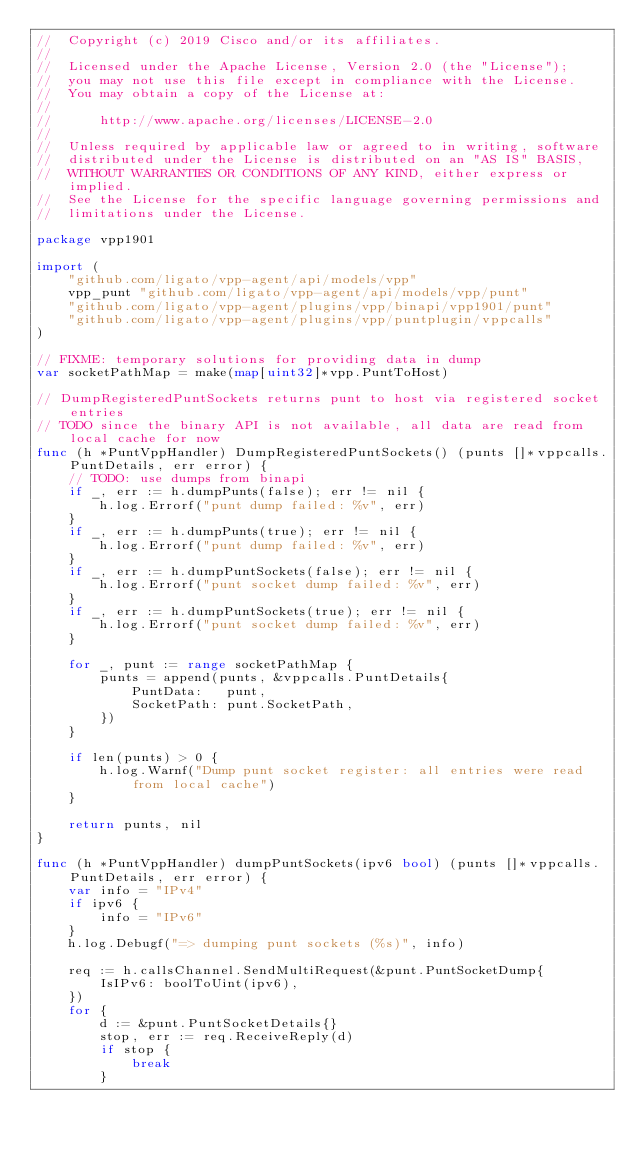Convert code to text. <code><loc_0><loc_0><loc_500><loc_500><_Go_>//  Copyright (c) 2019 Cisco and/or its affiliates.
//
//  Licensed under the Apache License, Version 2.0 (the "License");
//  you may not use this file except in compliance with the License.
//  You may obtain a copy of the License at:
//
//      http://www.apache.org/licenses/LICENSE-2.0
//
//  Unless required by applicable law or agreed to in writing, software
//  distributed under the License is distributed on an "AS IS" BASIS,
//  WITHOUT WARRANTIES OR CONDITIONS OF ANY KIND, either express or implied.
//  See the License for the specific language governing permissions and
//  limitations under the License.

package vpp1901

import (
	"github.com/ligato/vpp-agent/api/models/vpp"
	vpp_punt "github.com/ligato/vpp-agent/api/models/vpp/punt"
	"github.com/ligato/vpp-agent/plugins/vpp/binapi/vpp1901/punt"
	"github.com/ligato/vpp-agent/plugins/vpp/puntplugin/vppcalls"
)

// FIXME: temporary solutions for providing data in dump
var socketPathMap = make(map[uint32]*vpp.PuntToHost)

// DumpRegisteredPuntSockets returns punt to host via registered socket entries
// TODO since the binary API is not available, all data are read from local cache for now
func (h *PuntVppHandler) DumpRegisteredPuntSockets() (punts []*vppcalls.PuntDetails, err error) {
	// TODO: use dumps from binapi
	if _, err := h.dumpPunts(false); err != nil {
		h.log.Errorf("punt dump failed: %v", err)
	}
	if _, err := h.dumpPunts(true); err != nil {
		h.log.Errorf("punt dump failed: %v", err)
	}
	if _, err := h.dumpPuntSockets(false); err != nil {
		h.log.Errorf("punt socket dump failed: %v", err)
	}
	if _, err := h.dumpPuntSockets(true); err != nil {
		h.log.Errorf("punt socket dump failed: %v", err)
	}

	for _, punt := range socketPathMap {
		punts = append(punts, &vppcalls.PuntDetails{
			PuntData:   punt,
			SocketPath: punt.SocketPath,
		})
	}

	if len(punts) > 0 {
		h.log.Warnf("Dump punt socket register: all entries were read from local cache")
	}

	return punts, nil
}

func (h *PuntVppHandler) dumpPuntSockets(ipv6 bool) (punts []*vppcalls.PuntDetails, err error) {
	var info = "IPv4"
	if ipv6 {
		info = "IPv6"
	}
	h.log.Debugf("=> dumping punt sockets (%s)", info)

	req := h.callsChannel.SendMultiRequest(&punt.PuntSocketDump{
		IsIPv6: boolToUint(ipv6),
	})
	for {
		d := &punt.PuntSocketDetails{}
		stop, err := req.ReceiveReply(d)
		if stop {
			break
		}</code> 